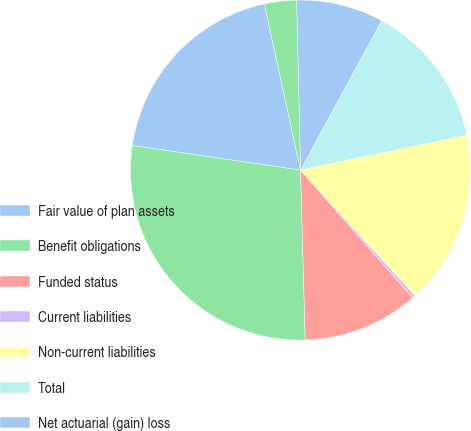<chart> <loc_0><loc_0><loc_500><loc_500><pie_chart><fcel>Fair value of plan assets<fcel>Benefit obligations<fcel>Funded status<fcel>Current liabilities<fcel>Non-current liabilities<fcel>Total<fcel>Net actuarial (gain) loss<fcel>Prior service cost (credit)<nl><fcel>19.28%<fcel>27.75%<fcel>11.04%<fcel>0.29%<fcel>16.53%<fcel>13.78%<fcel>8.29%<fcel>3.04%<nl></chart> 